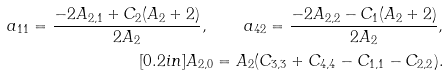<formula> <loc_0><loc_0><loc_500><loc_500>a _ { 1 1 } = \frac { - 2 A _ { 2 , 1 } + C _ { 2 } ( A _ { 2 } + 2 ) } { 2 A _ { 2 } } , \quad a _ { 4 2 } = \frac { - 2 A _ { 2 , 2 } - C _ { 1 } ( A _ { 2 } + 2 ) } { 2 A _ { 2 } } , \\ [ 0 . 2 i n ] A _ { 2 , 0 } = A _ { 2 } ( C _ { 3 , 3 } + C _ { 4 , 4 } - C _ { 1 , 1 } - C _ { 2 , 2 } ) .</formula> 